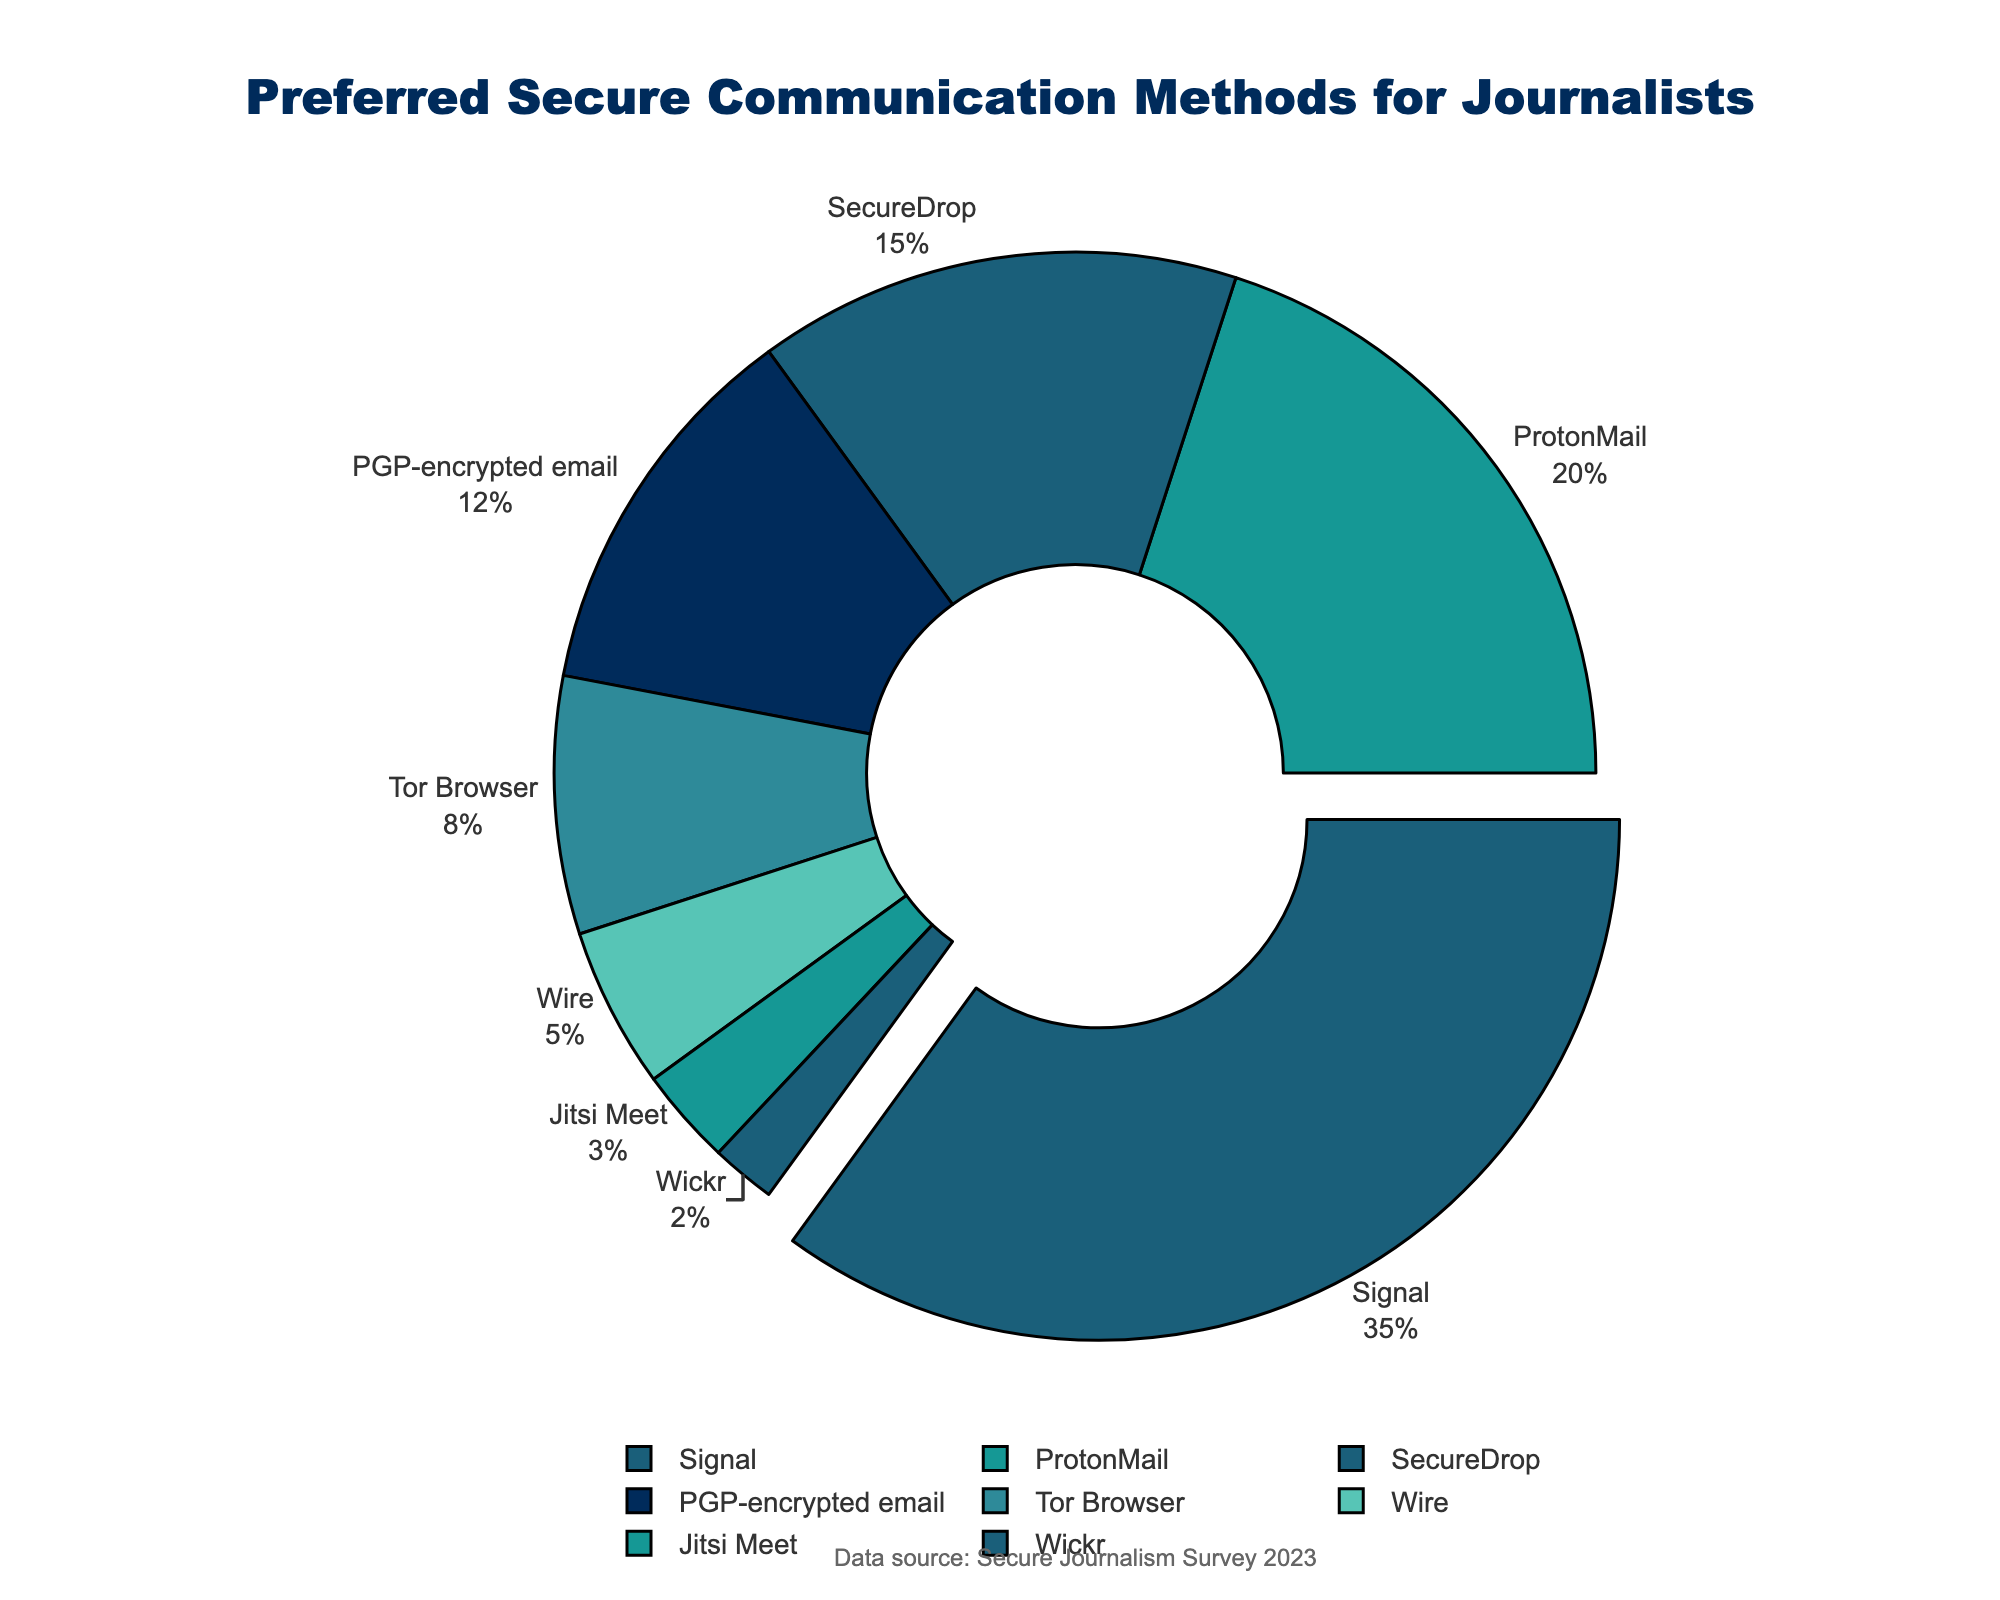What's the most preferred method for secure communication among journalists? The largest section of the pie chart is pulled out and labeled with the highest percentage. This section represents the most preferred method.
Answer: Signal What's the combined percentage of journalists using ProtonMail and SecureDrop? Add the percentages of ProtonMail (20%) and SecureDrop (15%) together.
Answer: 35% How many methods have a usage percentage lower than 10%? Identify the sections of the pie chart with percentage labels lower than 10%: Tor Browser (8%), Wire (5%), Jitsi Meet (3%), and Wickr (2%). There are four such methods.
Answer: 4 Which method has the least preference among journalists? The smallest section of the pie chart represents the least preferred method.
Answer: Wickr Are more journalists using PGP-encrypted email or Tor Browser? Compare the percentages of PGP-encrypted email (12%) and Tor Browser (8%).
Answer: PGP-encrypted email What percentage of journalists prefers Wire over Jitsi Meet? To find the difference, subtract Jitsi Meet's percentage (3%) from Wire's (5%).
Answer: 2% Is the percentage of journalists using Signal greater than the combined percentage of those using PGP-encrypted email and Tor Browser? Compare Signal's percentage (35%) with the sum of PGP-encrypted email (12%) and Tor Browser (8%), which is 20%. Since 35% is greater than 20%, the answer is yes.
Answer: Yes What is the sum of percentages for methods preferred by fewer than 5% of journalists? Sum the percentages of Wire (5%), Jitsi Meet (3%), and Wickr (2%).
Answer: 10% Which method is more popular: SecureDrop or ProtonMail? Compare the percentages of SecureDrop (15%) and ProtonMail (20%). ProtonMail has the higher percentage.
Answer: ProtonMail Is there a significant gap between the first and second most preferred methods? Compare the percentage of Signal (35%) with ProtonMail (20%), and subtract the smaller from the larger (35% - 20%). A difference of 15% signifies a significant gap.
Answer: Yes 